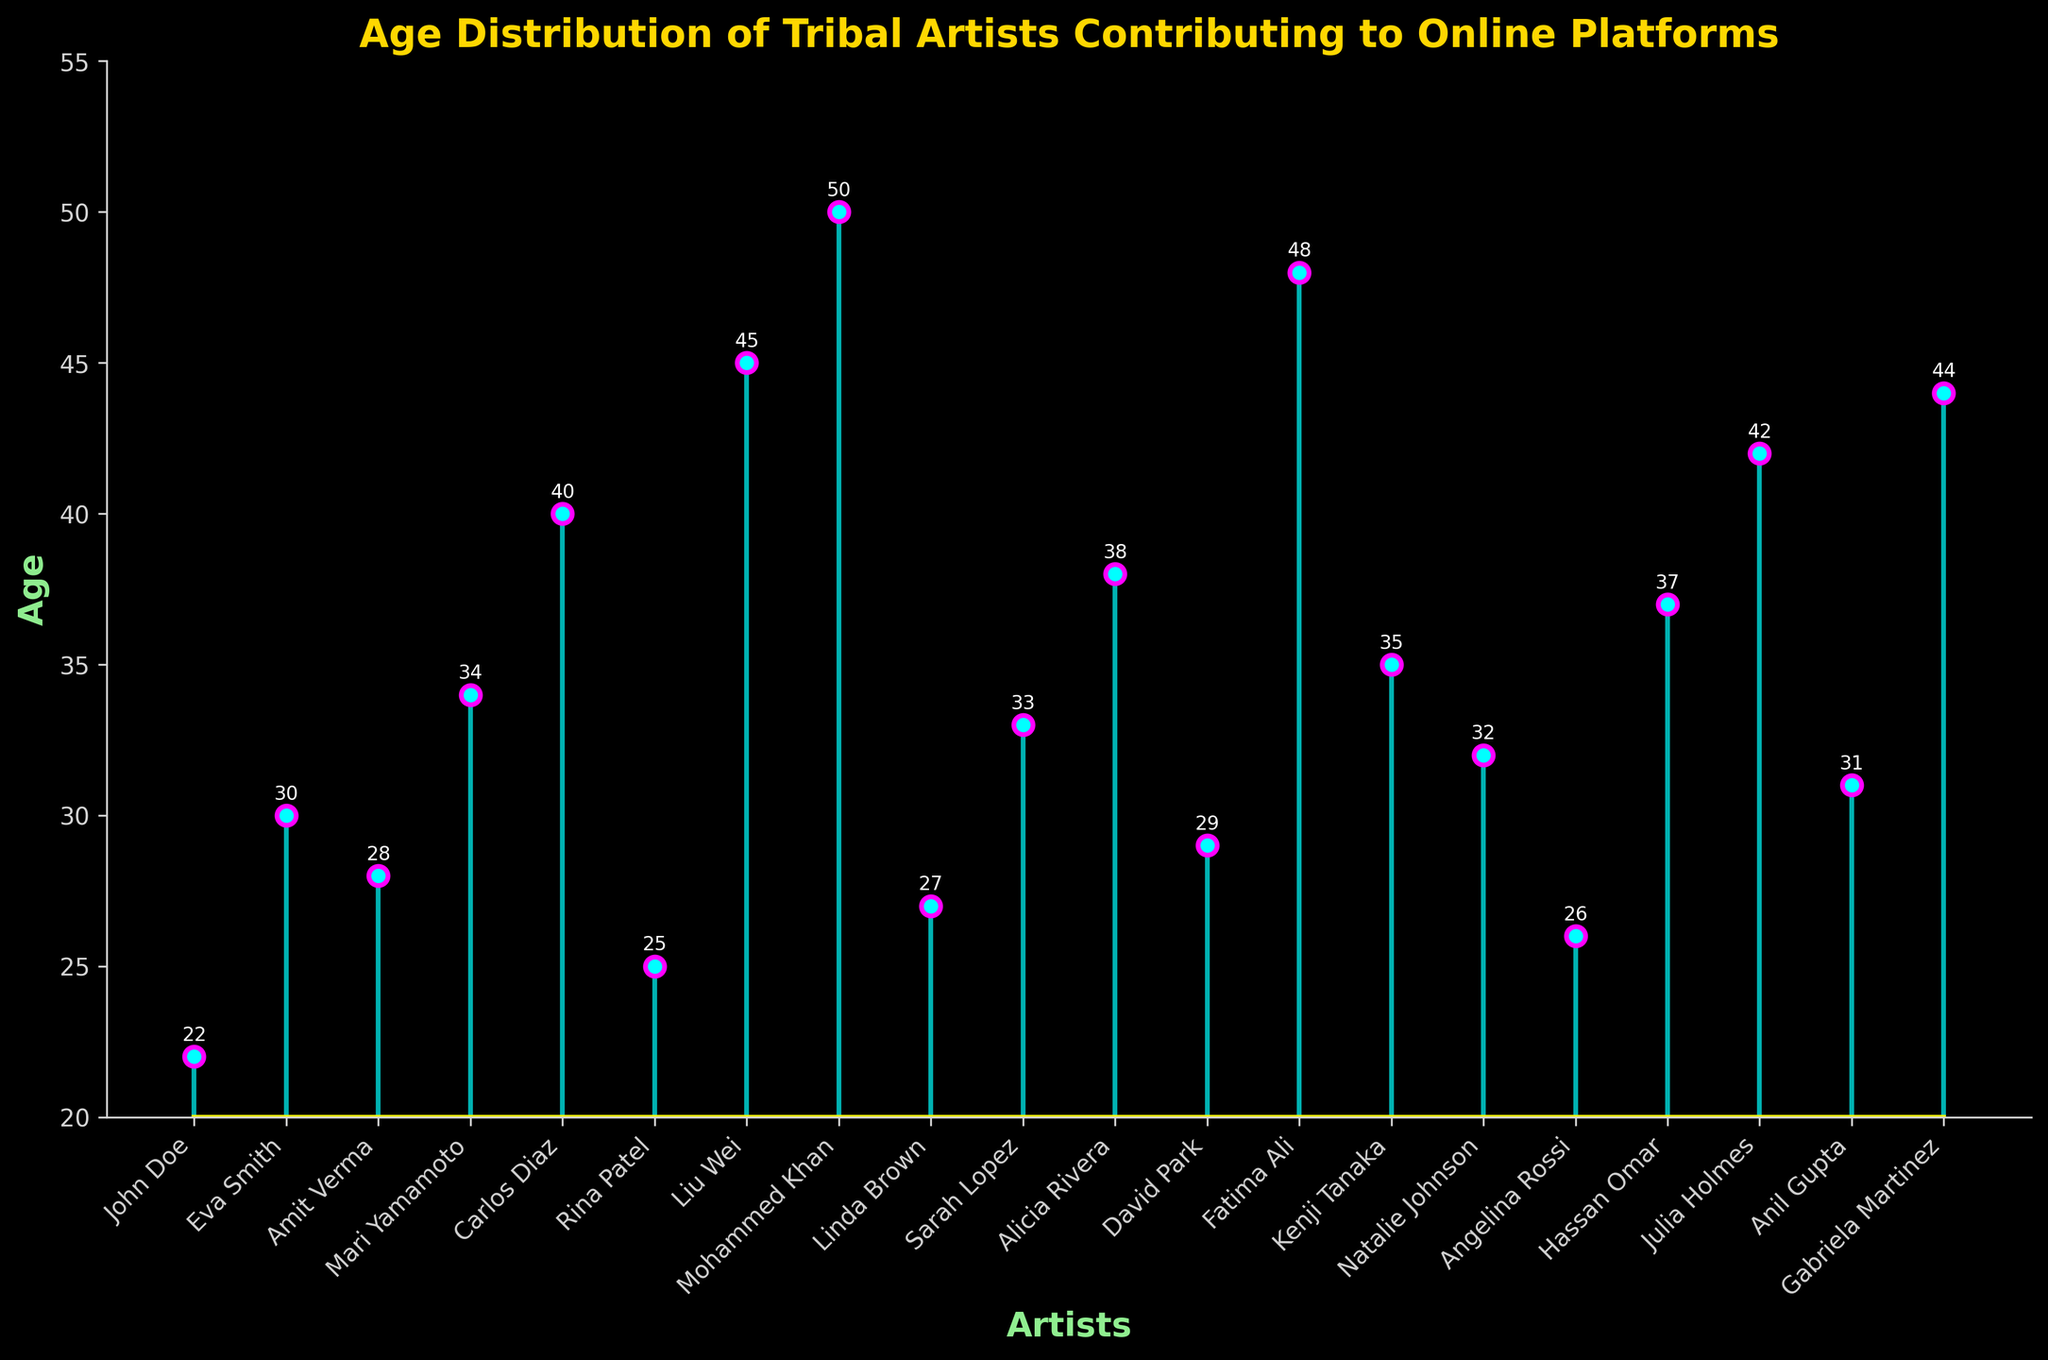What is the title of the plot? The title is located at the top of the plot and is typically used to give an overview of what the figure represents. The title in the provided figure reads "Age Distribution of Tribal Artists Contributing to Online Platforms".
Answer: Age Distribution of Tribal Artists Contributing to Online Platforms What is the range of ages represented in the plot? To find the range of ages, look at the lowest and highest ages plotted on the vertical axis. The ages in the figure range from 22 to 50.
Answer: 22 to 50 How many artists are shown in the plot? Each data point on the stem plot represents one artist. Counting the total number of artists listed on the horizontal axis provides the total number of artists. There are 19 artists in the plot.
Answer: 19 Who is the oldest artist in the plot? The age of each artist is displayed above each data point. The highest value is 50, attributed to Mohammed Khan.
Answer: Mohammed Khan What is the average age of the artists? To find the average age, sum all the ages and divide by the number of artists. The ages are: 22, 30, 28, 34, 40, 25, 45, 50, 27, 33, 38, 29, 48, 35, 32, 26, 37, 42, 31, 44. Sum them up to get 666, then divide by 19.
Answer: 35.05 Which artist is represented by the highest stem line? The artist corresponding to the highest age value will be represented by the highest stem line. This artist is Mohammed Khan, aged 50.
Answer: Mohammed Khan How many artists are older than 40? Identify and count all data points where ages are greater than 40. There are six ages over 40: 45, 50, 42, 48, and 44 represented by Liu Wei, Mohammed Khan, Julia Holmes, Fatima Ali, and Gabriela Martinez.
Answer: 5 What is the most common age range for the artists? To find the most common age range, observe which age bracket (e.g., 20-30, 31-40, 41-50) has the most artists. The bracket 20-30 contains more artists: John Doe, Eva Smith, Amit Verma, Rina Patel, Linda Brown, David Park, Angelina Rossi (7 artists).
Answer: 20-30 Who is older, Carlos Diaz or Kenji Tanaka? To determine which artist is older, compare their ages. Carlos Diaz is 40, and Kenji Tanaka is 35.
Answer: Carlos Diaz What is the difference in age between the youngest and the oldest artist? Subtract the age of the youngest artist (22) from the age of the oldest artist (50). The difference is 50 - 22.
Answer: 28 